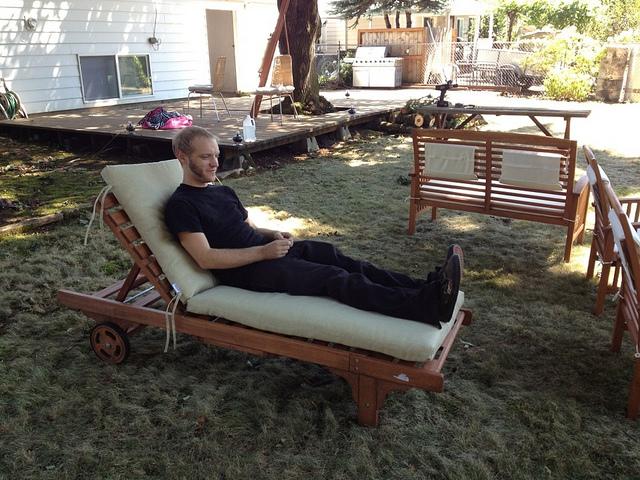Is this man inside?
Give a very brief answer. No. Is the man sleeping?
Be succinct. No. What is the man sitting on?
Give a very brief answer. Chair. Is there anyone sitting in the chair?
Quick response, please. Yes. Is there people on the bench?
Concise answer only. No. Is this a home?
Keep it brief. Yes. 